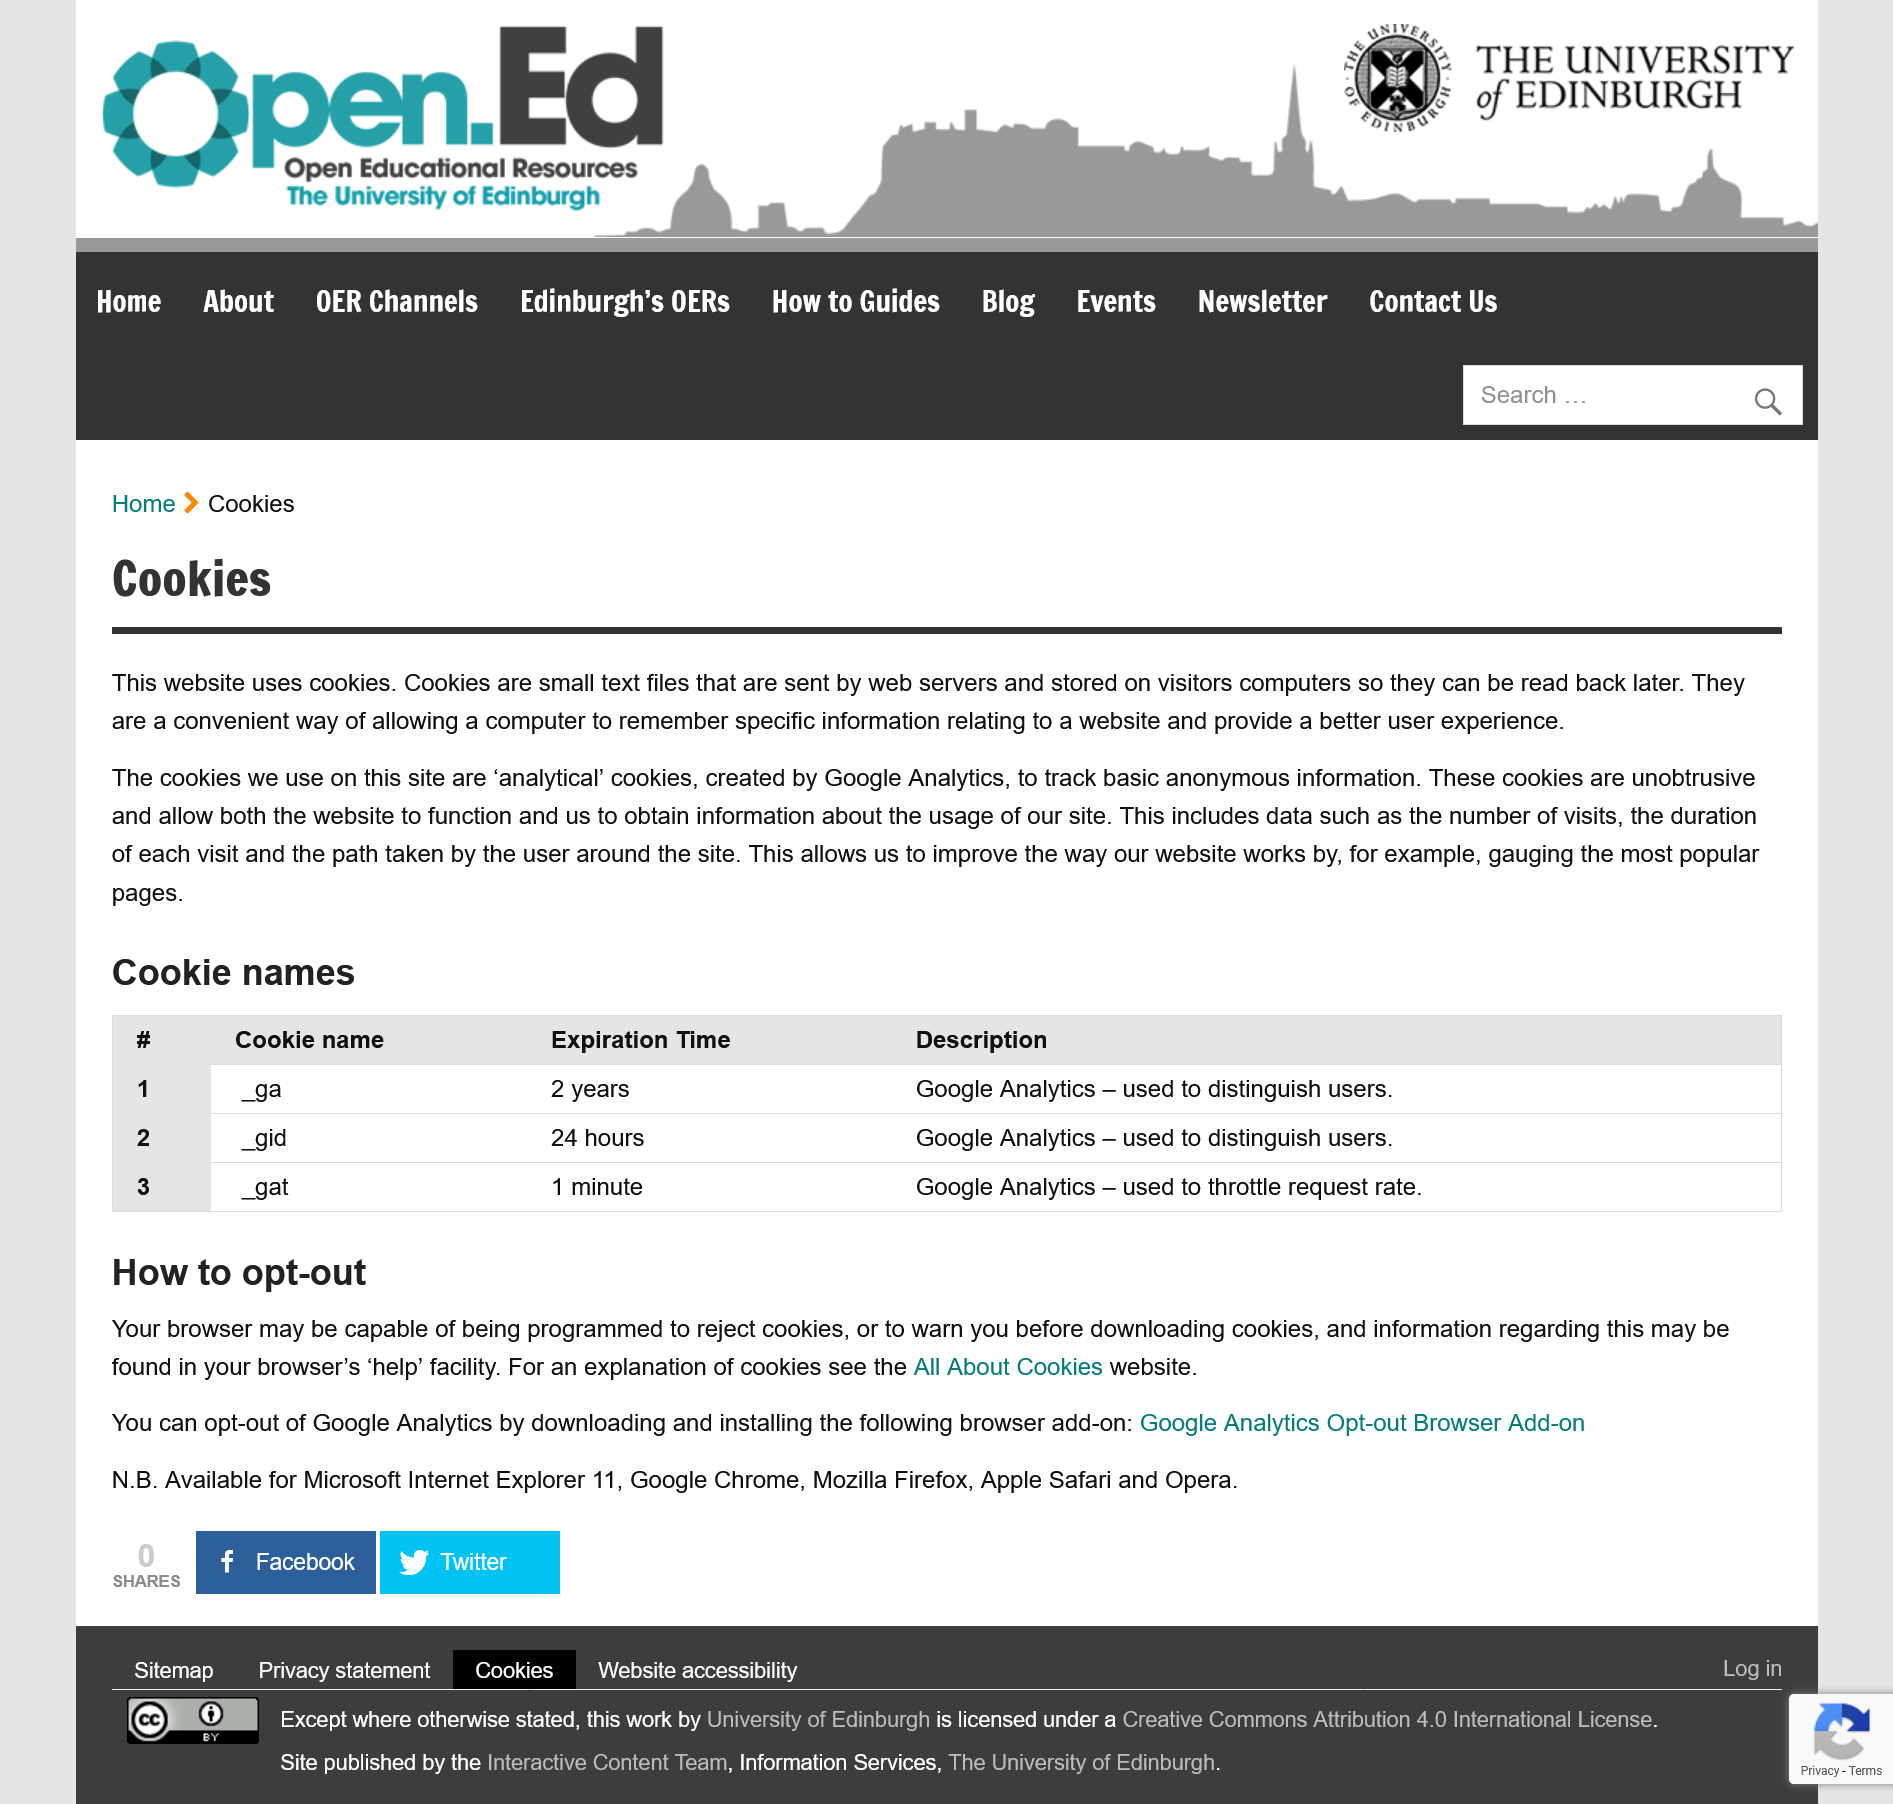Specify some key components in this picture. Cookies are small text files that are sent by web servers to visitors' computers and stored on their devices for future reference. This website utilizes cookies. 